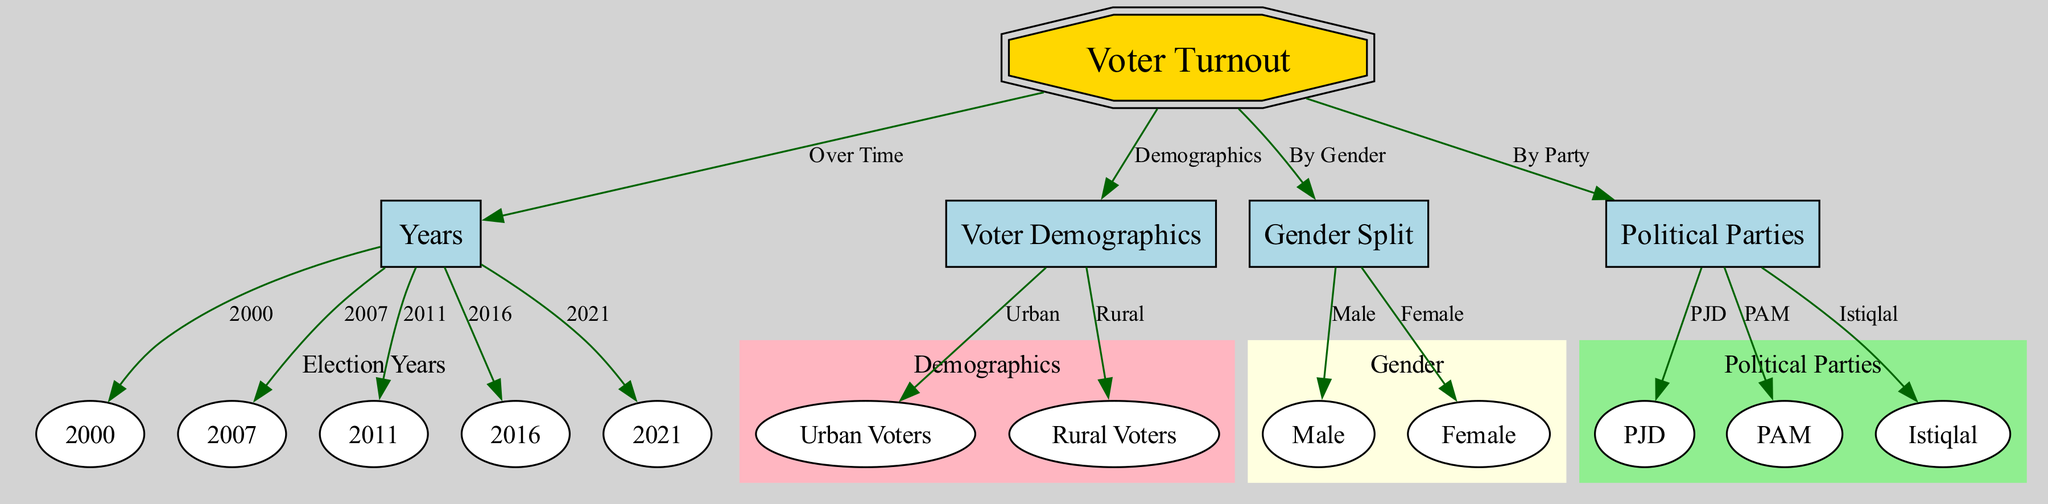What is the central theme of the diagram? The "Voter Turnout" node is labeled as the central node and connects to various elements in the diagram, indicating that it is the main subject of analysis concerning voter participation in Moroccan elections.
Answer: Voter Turnout How many election years are depicted in the diagram? There are five discrete years (2000, 2007, 2011, 2016, 2021) listed under the "Years" category, illustrating the time span of the voter turnout analysis.
Answer: 5 What demographic group is listed as a category in the diagram? The diagram includes "Urban Voters" and "Rural Voters" under the "Voter Demographics" category, defining two distinct groups for analysis regarding voter turnout.
Answer: Urban Voters Which political party is mentioned first in the diagram? The "PJD" node is listed first under the "Political Parties" category, indicating its position as a significant entity in the analysis of voter turnout by political affiliation.
Answer: PJD How is voter turnout segmented in the diagram? The diagram segments voter turnout by "Demographics", "By Gender", and "By Party", indicating a comprehensive analytical approach that incorporates multiple dimensions for assessing the voting behavior.
Answer: Demographics, Gender, Party What is the relationship between “Voter Turnout” and “Political Parties”? The edge labeled "By Party" connects the "Voter Turnout" node to the "Political Parties" category, indicating that voter participation is analyzed in relation to different political affiliations.
Answer: By Party Which gender is represented as a lower participant in voter turnout? The node "Female" under the "Gender Split" category indicates a specific demographic focus regarding female participation in elections, although the diagram does not explicitly show comparative values.
Answer: Female What is the geographical distinction made in voter demographics? The diagram makes a distinction between "Urban Voters" and "Rural Voters," highlighting the geographical variation in political participation within Moroccan elections.
Answer: Urban and Rural Which two nodes are connected under the "Gender Split"? The "Male" and "Female" nodes are directly connected under the "Gender Split" category, signifying an analysis of voter turnout based on gender.
Answer: Male and Female How does the diagram illustrate the change in voter turnout over time? The "Years" category connects to individual years (2000, 2007, 2011, 2016, 2021) which allows for a chronological analysis of how voter turnout has evolved across these specific election years.
Answer: Over Time 